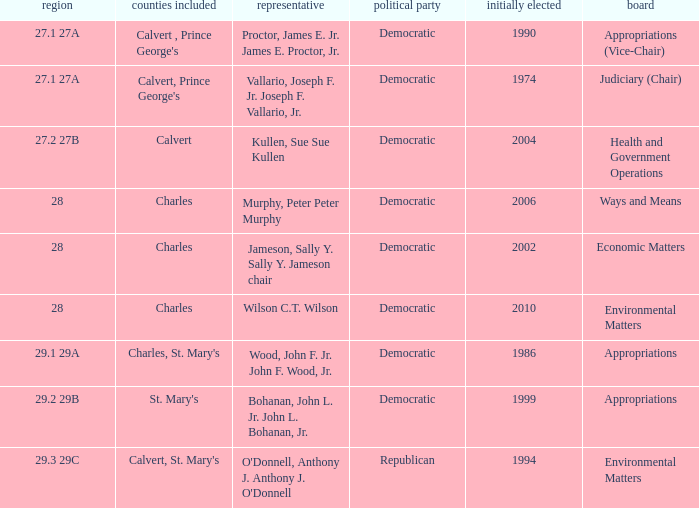When first elected was 2006, who was the delegate? Murphy, Peter Peter Murphy. 